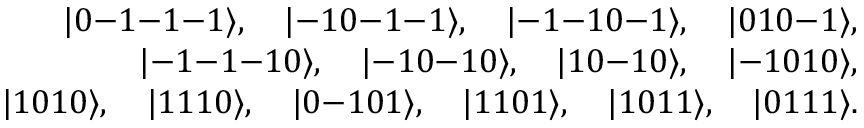Convert formula to latex. <formula><loc_0><loc_0><loc_500><loc_500>\begin{array} { r } { | 0 - 1 - 1 - 1 \rangle , \quad | - 1 0 - 1 - 1 \rangle , \quad | - 1 - 1 0 - 1 \rangle , \quad | 0 1 0 - 1 \rangle , } \\ { | - 1 - 1 - 1 0 \rangle , \quad | - 1 0 - 1 0 \rangle , \quad | 1 0 - 1 0 \rangle , \quad | - 1 0 1 0 \rangle , } \\ { | 1 0 1 0 \rangle , \quad | 1 1 1 0 \rangle , \quad | 0 - 1 0 1 \rangle , \quad | 1 1 0 1 \rangle , \quad | 1 0 1 1 \rangle , \quad | 0 1 1 1 \rangle . } \end{array}</formula> 